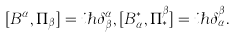Convert formula to latex. <formula><loc_0><loc_0><loc_500><loc_500>[ B ^ { \alpha } , \Pi _ { \beta } ] = i \hbar { \delta } _ { \beta } ^ { \alpha } , [ B _ { \alpha } ^ { \ast } , \Pi _ { \ast } ^ { \beta } ] = i \hbar { \delta } _ { \alpha } ^ { \beta } .</formula> 